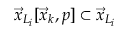Convert formula to latex. <formula><loc_0><loc_0><loc_500><loc_500>\vec { x } _ { L _ { i } } [ \vec { x } _ { k } , p ] \subset \vec { x } _ { L _ { i } }</formula> 